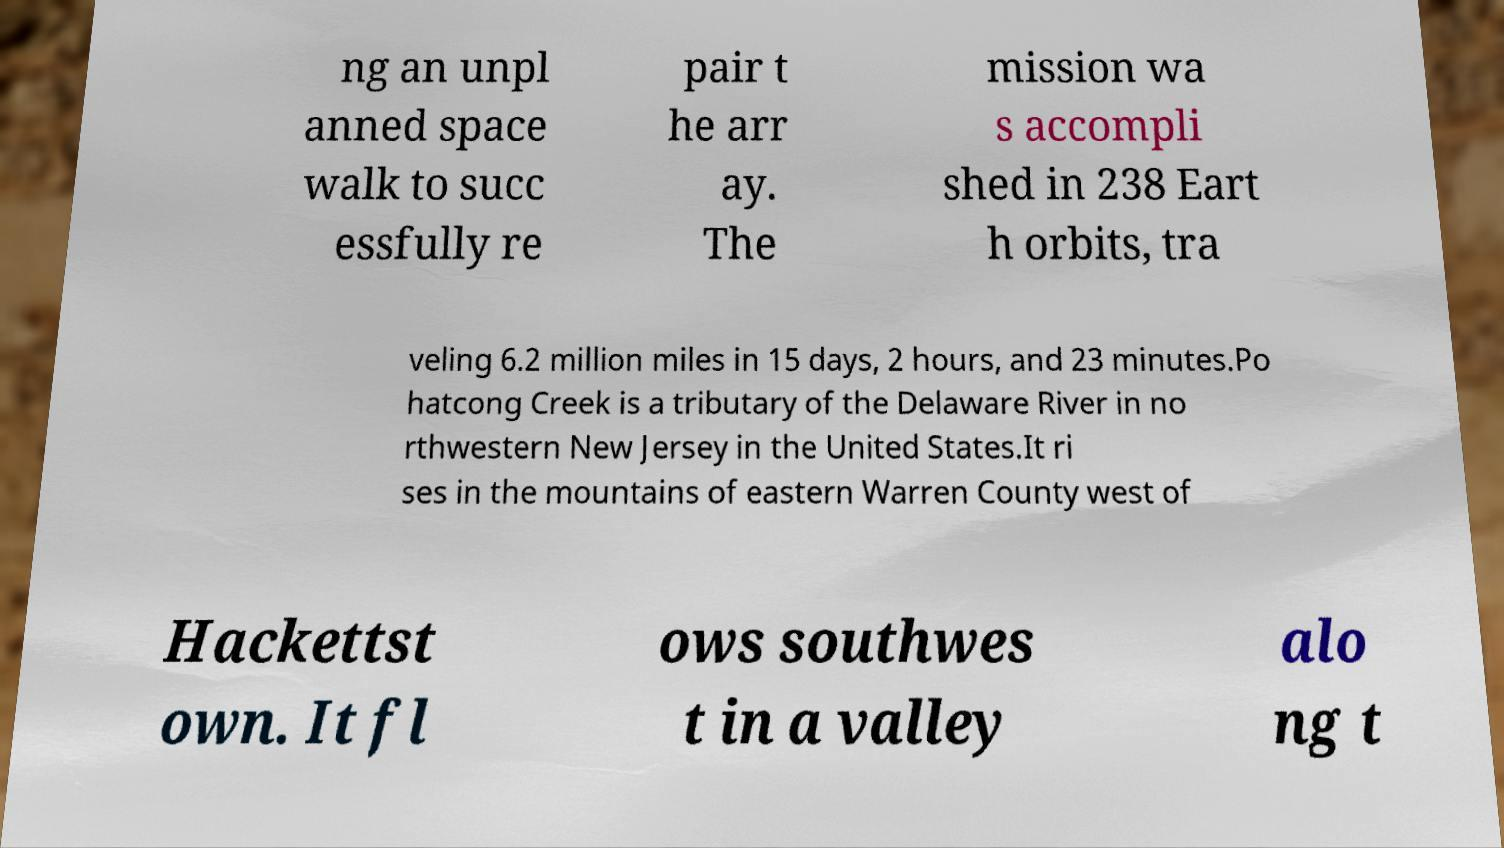Could you assist in decoding the text presented in this image and type it out clearly? ng an unpl anned space walk to succ essfully re pair t he arr ay. The mission wa s accompli shed in 238 Eart h orbits, tra veling 6.2 million miles in 15 days, 2 hours, and 23 minutes.Po hatcong Creek is a tributary of the Delaware River in no rthwestern New Jersey in the United States.It ri ses in the mountains of eastern Warren County west of Hackettst own. It fl ows southwes t in a valley alo ng t 